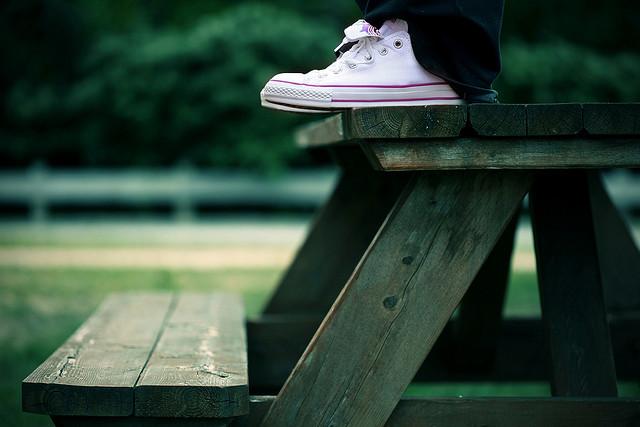What color are the shoes?
Write a very short answer. White. Are sneakers what this piece of outdoor furniture is intended to hold?
Be succinct. No. What is this person standing on?
Keep it brief. Picnic table. 